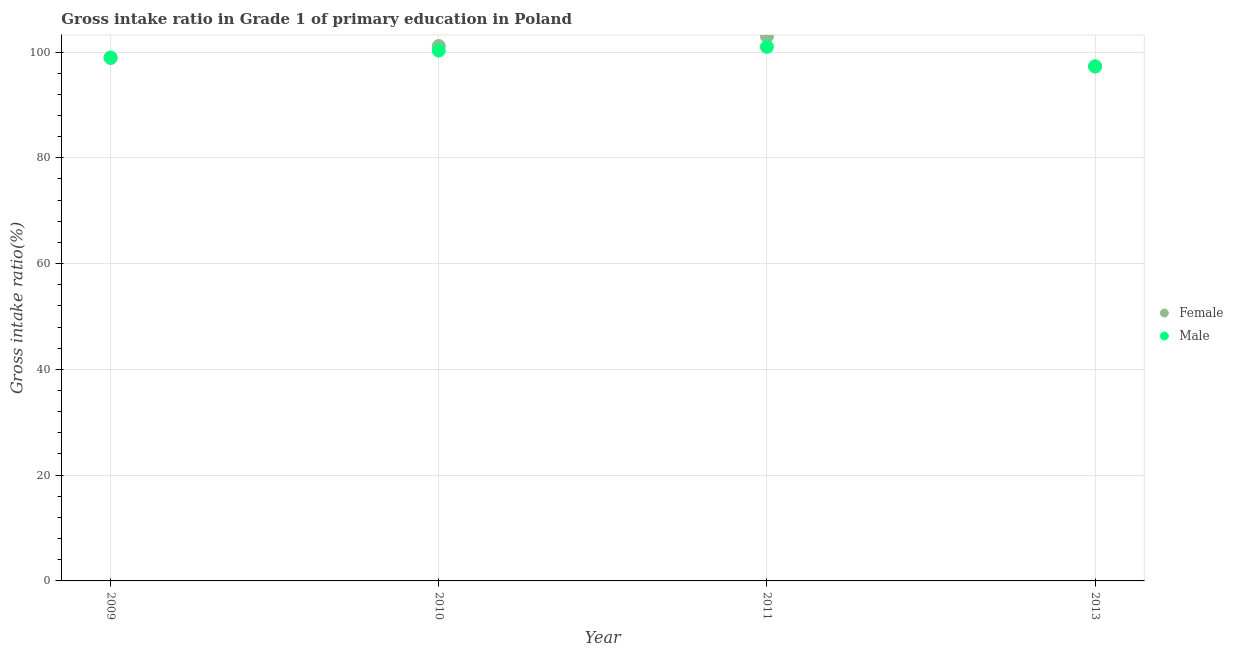What is the gross intake ratio(male) in 2009?
Make the answer very short. 98.96. Across all years, what is the maximum gross intake ratio(female)?
Your answer should be very brief. 102.95. Across all years, what is the minimum gross intake ratio(male)?
Offer a terse response. 97.3. In which year was the gross intake ratio(female) minimum?
Your response must be concise. 2013. What is the total gross intake ratio(female) in the graph?
Offer a terse response. 400.18. What is the difference between the gross intake ratio(male) in 2009 and that in 2010?
Offer a terse response. -1.3. What is the difference between the gross intake ratio(female) in 2011 and the gross intake ratio(male) in 2010?
Offer a very short reply. 2.68. What is the average gross intake ratio(female) per year?
Your answer should be compact. 100.05. In the year 2013, what is the difference between the gross intake ratio(male) and gross intake ratio(female)?
Give a very brief answer. 0.05. What is the ratio of the gross intake ratio(female) in 2011 to that in 2013?
Offer a very short reply. 1.06. Is the difference between the gross intake ratio(male) in 2009 and 2011 greater than the difference between the gross intake ratio(female) in 2009 and 2011?
Provide a succinct answer. Yes. What is the difference between the highest and the second highest gross intake ratio(male)?
Ensure brevity in your answer.  0.71. What is the difference between the highest and the lowest gross intake ratio(female)?
Your response must be concise. 5.7. Does the gross intake ratio(male) monotonically increase over the years?
Give a very brief answer. No. Is the gross intake ratio(male) strictly greater than the gross intake ratio(female) over the years?
Ensure brevity in your answer.  No. How many years are there in the graph?
Offer a very short reply. 4. Does the graph contain any zero values?
Your answer should be compact. No. How many legend labels are there?
Your response must be concise. 2. What is the title of the graph?
Make the answer very short. Gross intake ratio in Grade 1 of primary education in Poland. What is the label or title of the Y-axis?
Ensure brevity in your answer.  Gross intake ratio(%). What is the Gross intake ratio(%) of Female in 2009?
Your response must be concise. 98.85. What is the Gross intake ratio(%) of Male in 2009?
Provide a short and direct response. 98.96. What is the Gross intake ratio(%) in Female in 2010?
Your answer should be compact. 101.13. What is the Gross intake ratio(%) of Male in 2010?
Keep it short and to the point. 100.27. What is the Gross intake ratio(%) of Female in 2011?
Offer a terse response. 102.95. What is the Gross intake ratio(%) of Male in 2011?
Offer a very short reply. 100.98. What is the Gross intake ratio(%) of Female in 2013?
Offer a very short reply. 97.25. What is the Gross intake ratio(%) of Male in 2013?
Keep it short and to the point. 97.3. Across all years, what is the maximum Gross intake ratio(%) of Female?
Provide a succinct answer. 102.95. Across all years, what is the maximum Gross intake ratio(%) in Male?
Give a very brief answer. 100.98. Across all years, what is the minimum Gross intake ratio(%) in Female?
Keep it short and to the point. 97.25. Across all years, what is the minimum Gross intake ratio(%) of Male?
Your answer should be very brief. 97.3. What is the total Gross intake ratio(%) in Female in the graph?
Your response must be concise. 400.18. What is the total Gross intake ratio(%) of Male in the graph?
Keep it short and to the point. 397.51. What is the difference between the Gross intake ratio(%) of Female in 2009 and that in 2010?
Offer a very short reply. -2.27. What is the difference between the Gross intake ratio(%) in Male in 2009 and that in 2010?
Ensure brevity in your answer.  -1.3. What is the difference between the Gross intake ratio(%) of Female in 2009 and that in 2011?
Your answer should be very brief. -4.1. What is the difference between the Gross intake ratio(%) in Male in 2009 and that in 2011?
Offer a terse response. -2.01. What is the difference between the Gross intake ratio(%) in Female in 2009 and that in 2013?
Keep it short and to the point. 1.61. What is the difference between the Gross intake ratio(%) in Male in 2009 and that in 2013?
Ensure brevity in your answer.  1.67. What is the difference between the Gross intake ratio(%) of Female in 2010 and that in 2011?
Provide a succinct answer. -1.83. What is the difference between the Gross intake ratio(%) in Male in 2010 and that in 2011?
Offer a terse response. -0.71. What is the difference between the Gross intake ratio(%) of Female in 2010 and that in 2013?
Provide a succinct answer. 3.88. What is the difference between the Gross intake ratio(%) of Male in 2010 and that in 2013?
Make the answer very short. 2.97. What is the difference between the Gross intake ratio(%) in Female in 2011 and that in 2013?
Ensure brevity in your answer.  5.7. What is the difference between the Gross intake ratio(%) of Male in 2011 and that in 2013?
Give a very brief answer. 3.68. What is the difference between the Gross intake ratio(%) of Female in 2009 and the Gross intake ratio(%) of Male in 2010?
Your answer should be very brief. -1.41. What is the difference between the Gross intake ratio(%) of Female in 2009 and the Gross intake ratio(%) of Male in 2011?
Your answer should be compact. -2.12. What is the difference between the Gross intake ratio(%) in Female in 2009 and the Gross intake ratio(%) in Male in 2013?
Offer a terse response. 1.56. What is the difference between the Gross intake ratio(%) of Female in 2010 and the Gross intake ratio(%) of Male in 2011?
Your answer should be very brief. 0.15. What is the difference between the Gross intake ratio(%) in Female in 2010 and the Gross intake ratio(%) in Male in 2013?
Offer a terse response. 3.83. What is the difference between the Gross intake ratio(%) of Female in 2011 and the Gross intake ratio(%) of Male in 2013?
Your response must be concise. 5.66. What is the average Gross intake ratio(%) in Female per year?
Offer a terse response. 100.05. What is the average Gross intake ratio(%) of Male per year?
Offer a terse response. 99.38. In the year 2009, what is the difference between the Gross intake ratio(%) in Female and Gross intake ratio(%) in Male?
Provide a succinct answer. -0.11. In the year 2010, what is the difference between the Gross intake ratio(%) of Female and Gross intake ratio(%) of Male?
Keep it short and to the point. 0.86. In the year 2011, what is the difference between the Gross intake ratio(%) in Female and Gross intake ratio(%) in Male?
Make the answer very short. 1.98. In the year 2013, what is the difference between the Gross intake ratio(%) of Female and Gross intake ratio(%) of Male?
Provide a succinct answer. -0.05. What is the ratio of the Gross intake ratio(%) of Female in 2009 to that in 2010?
Your answer should be very brief. 0.98. What is the ratio of the Gross intake ratio(%) in Female in 2009 to that in 2011?
Ensure brevity in your answer.  0.96. What is the ratio of the Gross intake ratio(%) in Male in 2009 to that in 2011?
Provide a short and direct response. 0.98. What is the ratio of the Gross intake ratio(%) in Female in 2009 to that in 2013?
Make the answer very short. 1.02. What is the ratio of the Gross intake ratio(%) of Male in 2009 to that in 2013?
Keep it short and to the point. 1.02. What is the ratio of the Gross intake ratio(%) in Female in 2010 to that in 2011?
Provide a succinct answer. 0.98. What is the ratio of the Gross intake ratio(%) of Male in 2010 to that in 2011?
Your answer should be compact. 0.99. What is the ratio of the Gross intake ratio(%) in Female in 2010 to that in 2013?
Make the answer very short. 1.04. What is the ratio of the Gross intake ratio(%) of Male in 2010 to that in 2013?
Make the answer very short. 1.03. What is the ratio of the Gross intake ratio(%) of Female in 2011 to that in 2013?
Make the answer very short. 1.06. What is the ratio of the Gross intake ratio(%) of Male in 2011 to that in 2013?
Provide a succinct answer. 1.04. What is the difference between the highest and the second highest Gross intake ratio(%) of Female?
Your response must be concise. 1.83. What is the difference between the highest and the second highest Gross intake ratio(%) in Male?
Offer a terse response. 0.71. What is the difference between the highest and the lowest Gross intake ratio(%) in Female?
Provide a succinct answer. 5.7. What is the difference between the highest and the lowest Gross intake ratio(%) in Male?
Provide a succinct answer. 3.68. 